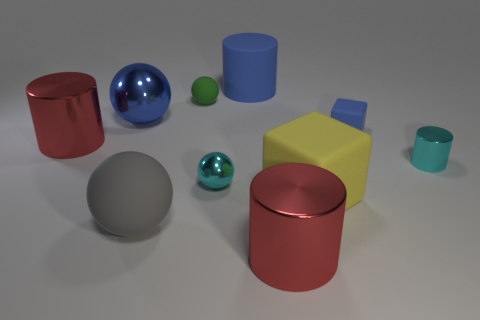The cyan object that is made of the same material as the tiny cyan ball is what size?
Your answer should be very brief. Small. Do the gray matte thing and the large metallic thing that is on the right side of the green ball have the same shape?
Your response must be concise. No. How big is the gray object?
Give a very brief answer. Large. Is the number of large metallic things that are on the right side of the large blue metallic ball less than the number of balls?
Keep it short and to the point. Yes. How many shiny balls are the same size as the green object?
Offer a very short reply. 1. There is a matte object that is the same color as the small block; what is its shape?
Provide a succinct answer. Cylinder. There is a large shiny object that is on the right side of the blue rubber cylinder; is its color the same as the small metallic object behind the small cyan shiny ball?
Provide a short and direct response. No. There is a yellow block; how many blue things are on the left side of it?
Offer a terse response. 2. The object that is the same color as the small shiny cylinder is what size?
Make the answer very short. Small. Is there a red metal object that has the same shape as the green rubber object?
Your response must be concise. No. 